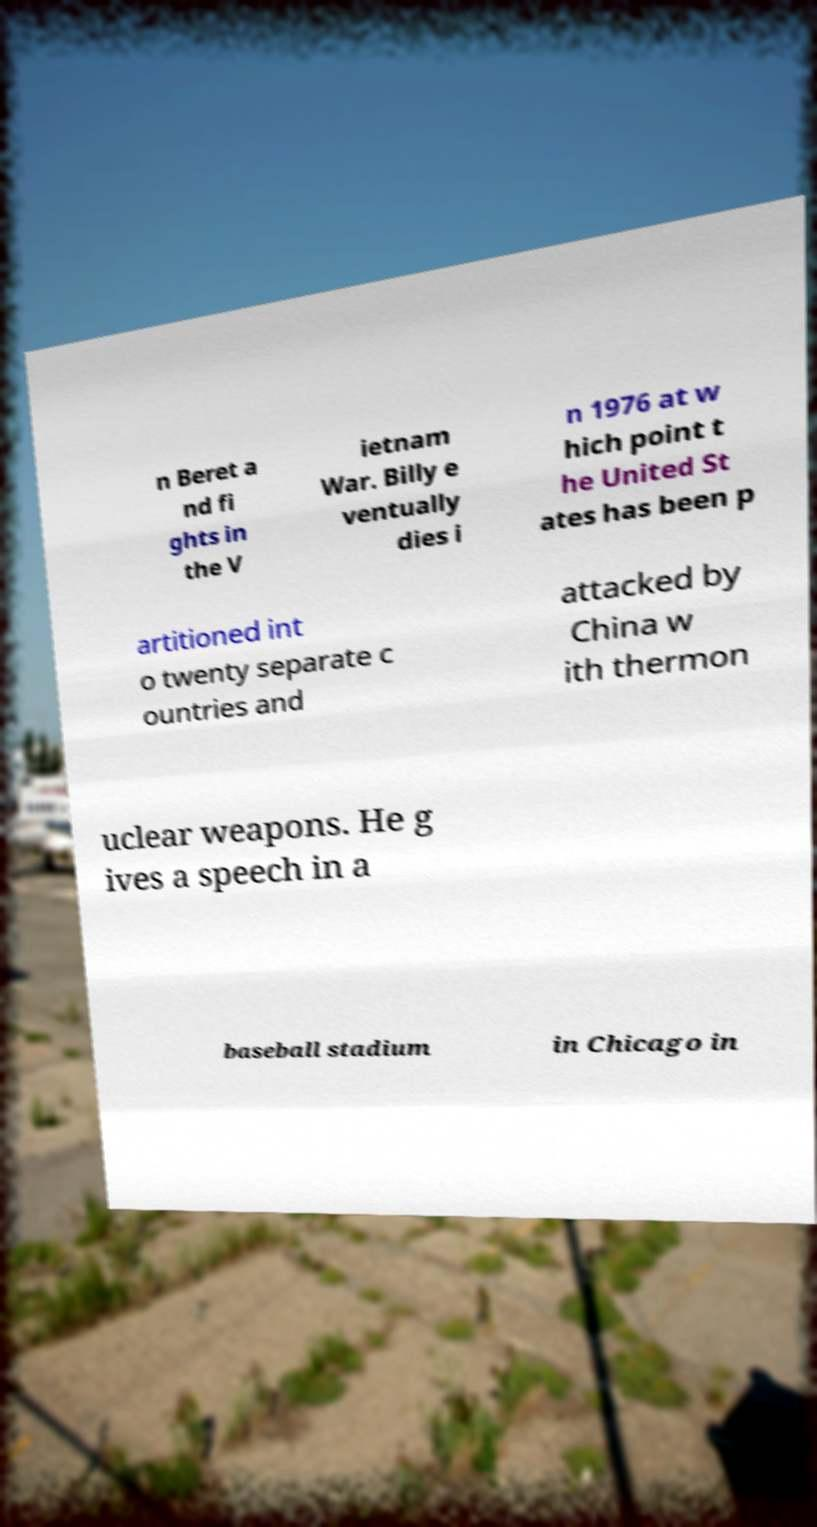Could you assist in decoding the text presented in this image and type it out clearly? n Beret a nd fi ghts in the V ietnam War. Billy e ventually dies i n 1976 at w hich point t he United St ates has been p artitioned int o twenty separate c ountries and attacked by China w ith thermon uclear weapons. He g ives a speech in a baseball stadium in Chicago in 